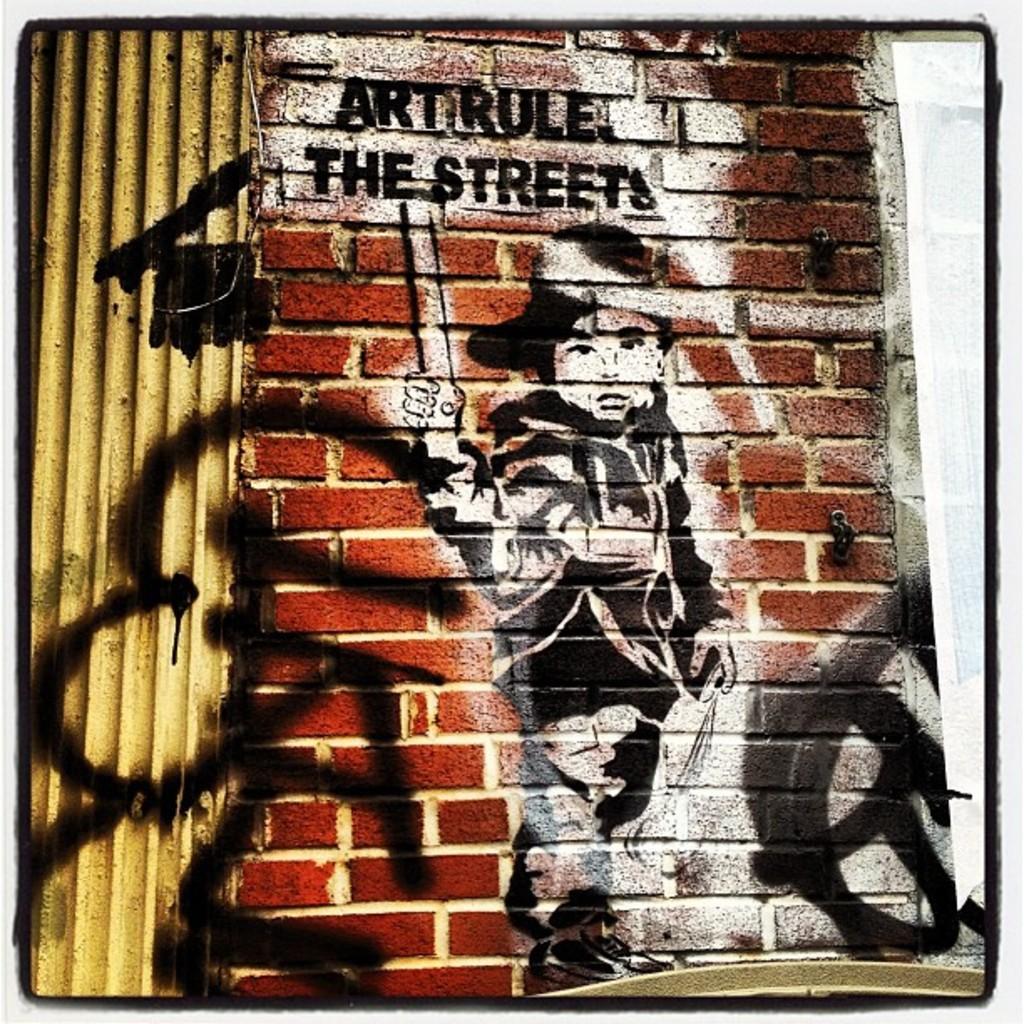Could you give a brief overview of what you see in this image? In this image, we can see a wall contains depiction of a person and some text. There is a metal frame on the left side of the image. 